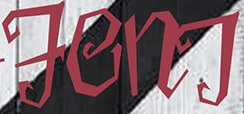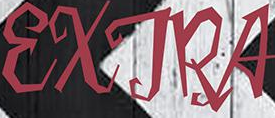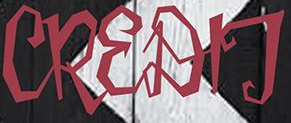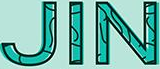What words can you see in these images in sequence, separated by a semicolon? FenT; EXTRA; CREDIT; JIN 